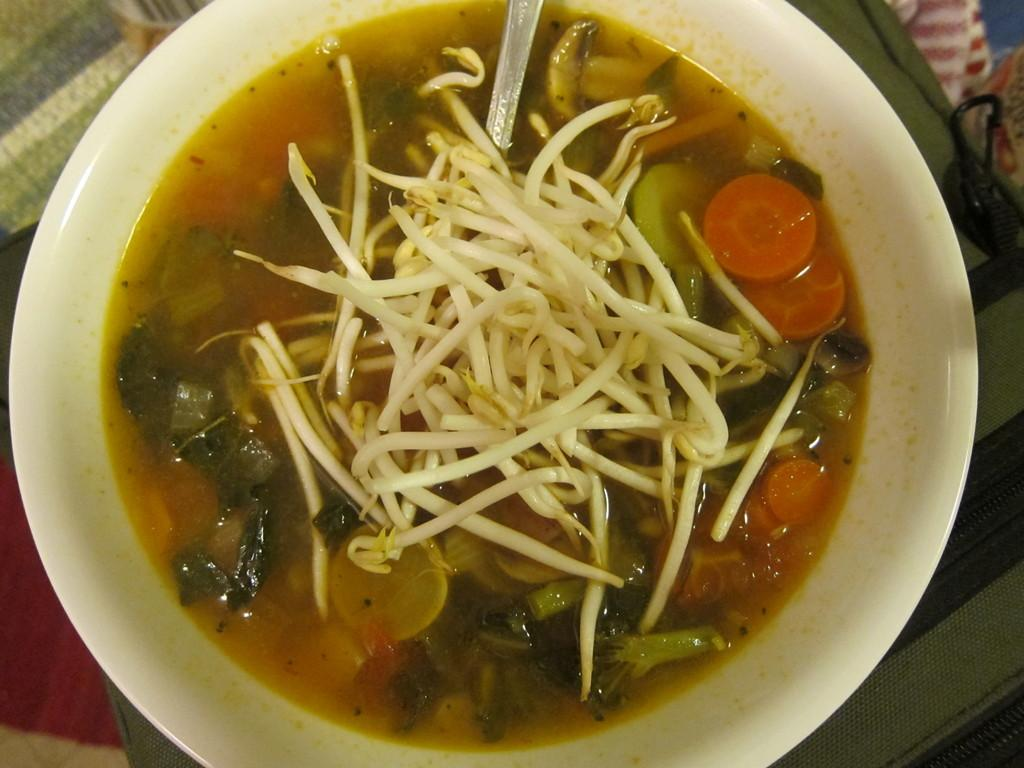What is in the bowl that is visible in the image? There is a food item in the bowl. What utensil is present in the bowl? There is a spoon in the bowl. What can be seen at the bottom of the image? There is a cloth at the bottom of the image. How many docks are visible in the image? There are no docks present in the image. What type of arithmetic problem is being solved in the image? There is no arithmetic problem visible in the image. 